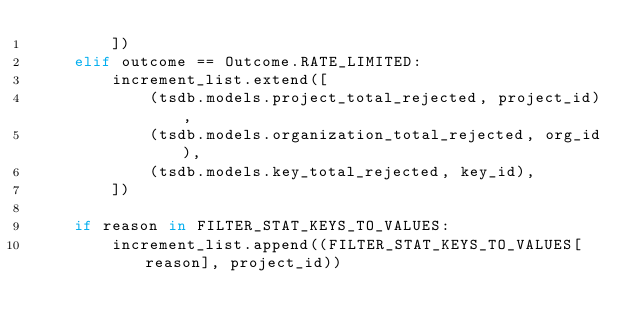Convert code to text. <code><loc_0><loc_0><loc_500><loc_500><_Python_>        ])
    elif outcome == Outcome.RATE_LIMITED:
        increment_list.extend([
            (tsdb.models.project_total_rejected, project_id),
            (tsdb.models.organization_total_rejected, org_id),
            (tsdb.models.key_total_rejected, key_id),
        ])

    if reason in FILTER_STAT_KEYS_TO_VALUES:
        increment_list.append((FILTER_STAT_KEYS_TO_VALUES[reason], project_id))
</code> 